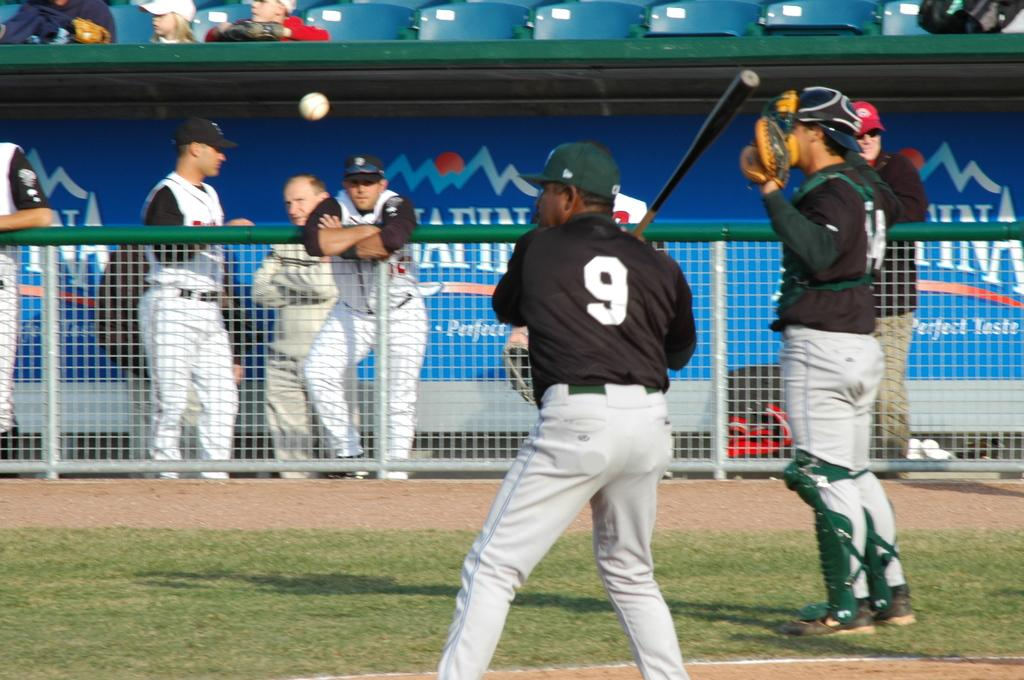<image>
Give a short and clear explanation of the subsequent image. Baseball players on the field with player 9 ready to hit the ball. 